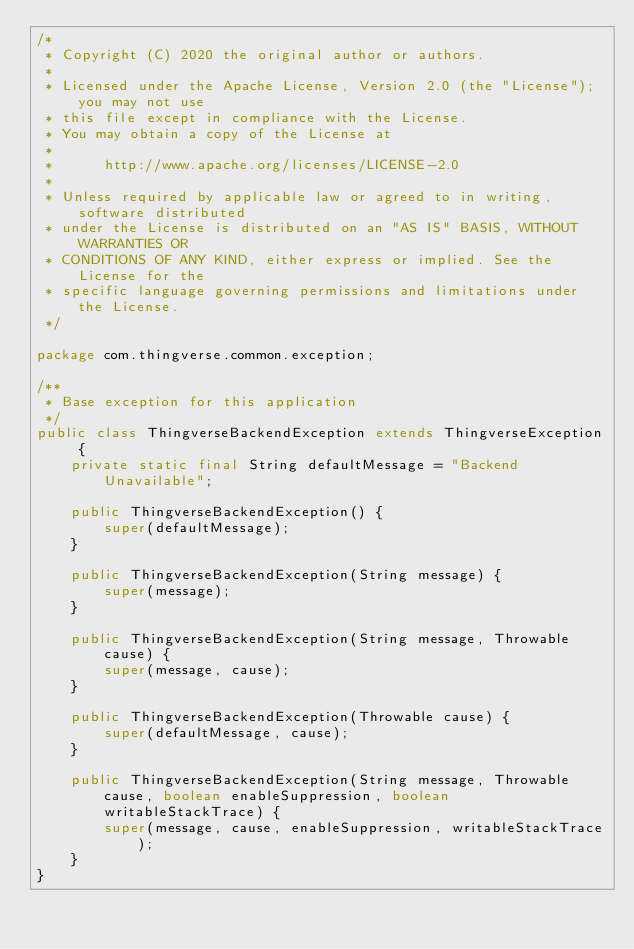<code> <loc_0><loc_0><loc_500><loc_500><_Java_>/*
 * Copyright (C) 2020 the original author or authors.
 *
 * Licensed under the Apache License, Version 2.0 (the "License"); you may not use
 * this file except in compliance with the License.
 * You may obtain a copy of the License at
 *
 *      http://www.apache.org/licenses/LICENSE-2.0
 *
 * Unless required by applicable law or agreed to in writing, software distributed
 * under the License is distributed on an "AS IS" BASIS, WITHOUT WARRANTIES OR
 * CONDITIONS OF ANY KIND, either express or implied. See the License for the
 * specific language governing permissions and limitations under the License.
 */

package com.thingverse.common.exception;

/**
 * Base exception for this application
 */
public class ThingverseBackendException extends ThingverseException {
    private static final String defaultMessage = "Backend Unavailable";

    public ThingverseBackendException() {
        super(defaultMessage);
    }

    public ThingverseBackendException(String message) {
        super(message);
    }

    public ThingverseBackendException(String message, Throwable cause) {
        super(message, cause);
    }

    public ThingverseBackendException(Throwable cause) {
        super(defaultMessage, cause);
    }

    public ThingverseBackendException(String message, Throwable cause, boolean enableSuppression, boolean writableStackTrace) {
        super(message, cause, enableSuppression, writableStackTrace);
    }
}
</code> 